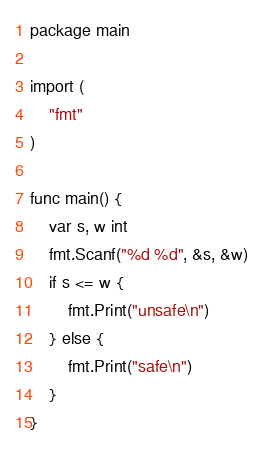Convert code to text. <code><loc_0><loc_0><loc_500><loc_500><_Go_>package main

import (
    "fmt"
)

func main() {
    var s, w int
    fmt.Scanf("%d %d", &s, &w)
    if s <= w {
        fmt.Print("unsafe\n")
    } else {
        fmt.Print("safe\n")
    }
}
</code> 